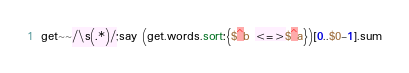Convert code to text. <code><loc_0><loc_0><loc_500><loc_500><_Perl_>get~~/\s(.*)/;say (get.words.sort:{$^b <=>$^a})[0..$0-1].sum</code> 